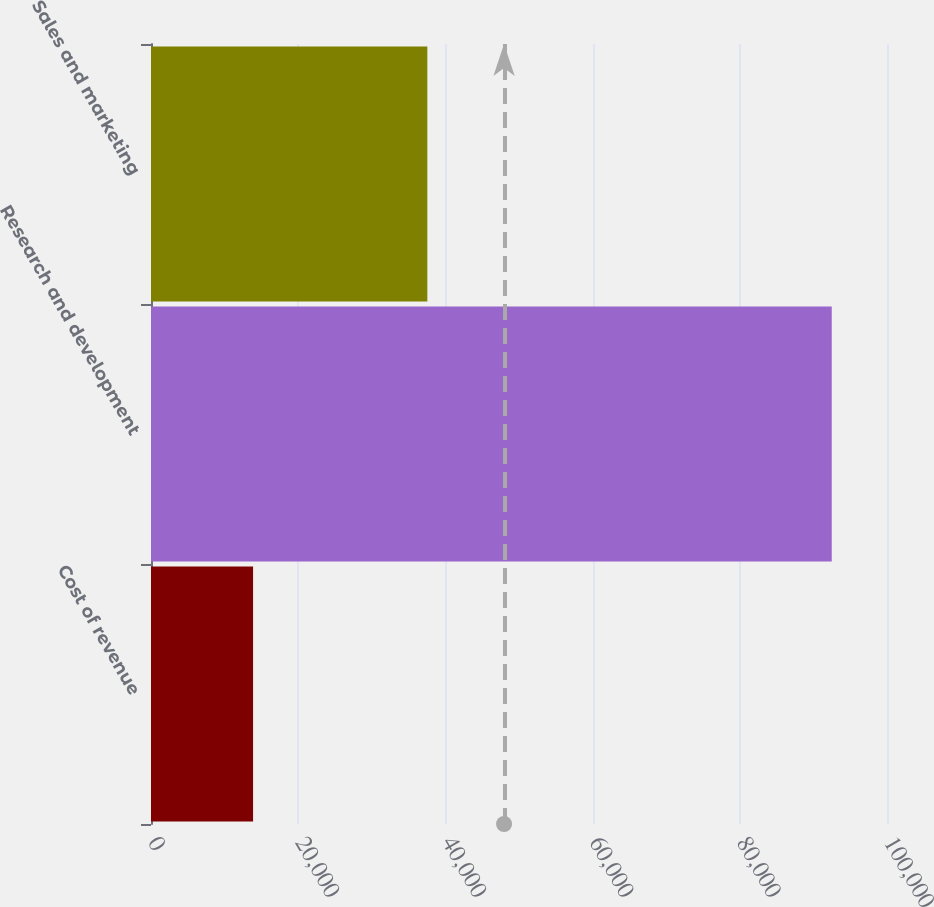<chart> <loc_0><loc_0><loc_500><loc_500><bar_chart><fcel>Cost of revenue<fcel>Research and development<fcel>Sales and marketing<nl><fcel>13869<fcel>92493<fcel>37547<nl></chart> 